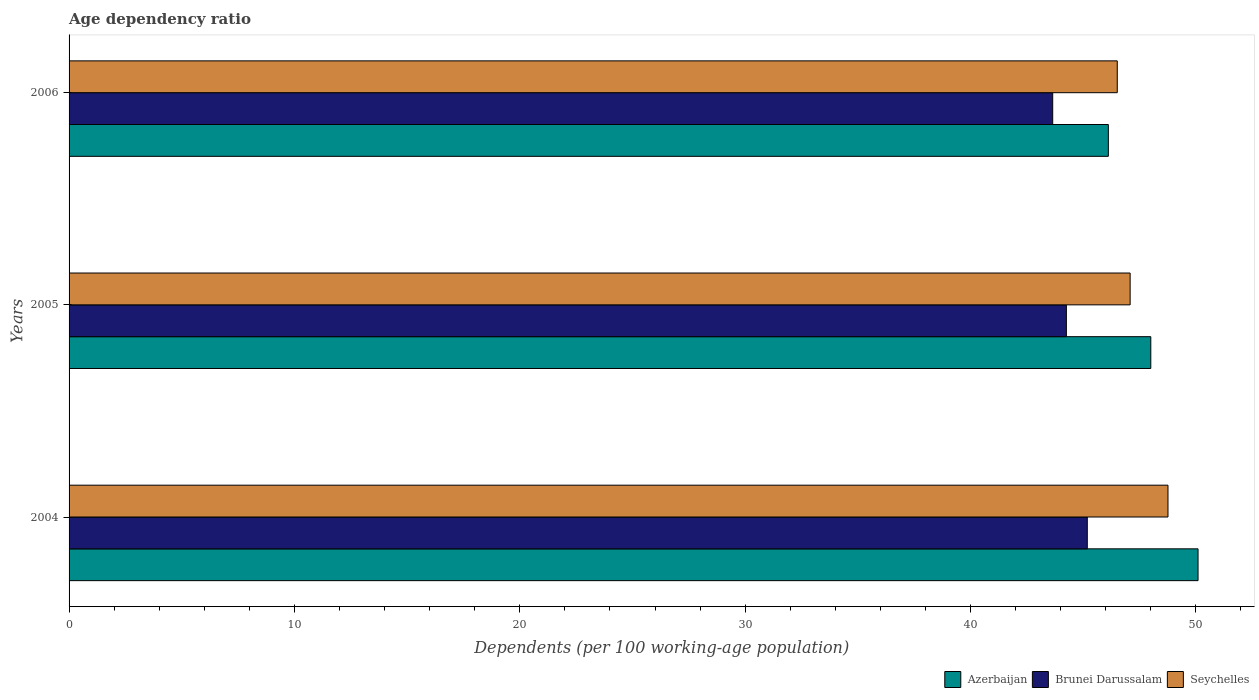How many groups of bars are there?
Provide a short and direct response. 3. Are the number of bars per tick equal to the number of legend labels?
Provide a short and direct response. Yes. How many bars are there on the 2nd tick from the top?
Your answer should be compact. 3. How many bars are there on the 2nd tick from the bottom?
Make the answer very short. 3. What is the label of the 2nd group of bars from the top?
Provide a succinct answer. 2005. In how many cases, is the number of bars for a given year not equal to the number of legend labels?
Your response must be concise. 0. What is the age dependency ratio in in Brunei Darussalam in 2006?
Your answer should be compact. 43.65. Across all years, what is the maximum age dependency ratio in in Brunei Darussalam?
Your answer should be very brief. 45.18. Across all years, what is the minimum age dependency ratio in in Brunei Darussalam?
Your response must be concise. 43.65. What is the total age dependency ratio in in Seychelles in the graph?
Your answer should be compact. 142.35. What is the difference between the age dependency ratio in in Azerbaijan in 2005 and that in 2006?
Your response must be concise. 1.88. What is the difference between the age dependency ratio in in Brunei Darussalam in 2004 and the age dependency ratio in in Azerbaijan in 2006?
Provide a succinct answer. -0.93. What is the average age dependency ratio in in Azerbaijan per year?
Make the answer very short. 48.07. In the year 2005, what is the difference between the age dependency ratio in in Azerbaijan and age dependency ratio in in Seychelles?
Ensure brevity in your answer.  0.92. What is the ratio of the age dependency ratio in in Brunei Darussalam in 2005 to that in 2006?
Provide a short and direct response. 1.01. Is the difference between the age dependency ratio in in Azerbaijan in 2004 and 2006 greater than the difference between the age dependency ratio in in Seychelles in 2004 and 2006?
Your answer should be very brief. Yes. What is the difference between the highest and the second highest age dependency ratio in in Brunei Darussalam?
Keep it short and to the point. 0.93. What is the difference between the highest and the lowest age dependency ratio in in Brunei Darussalam?
Give a very brief answer. 1.53. Is the sum of the age dependency ratio in in Seychelles in 2005 and 2006 greater than the maximum age dependency ratio in in Azerbaijan across all years?
Offer a terse response. Yes. What does the 2nd bar from the top in 2006 represents?
Provide a short and direct response. Brunei Darussalam. What does the 2nd bar from the bottom in 2006 represents?
Keep it short and to the point. Brunei Darussalam. Is it the case that in every year, the sum of the age dependency ratio in in Brunei Darussalam and age dependency ratio in in Azerbaijan is greater than the age dependency ratio in in Seychelles?
Your response must be concise. Yes. How many bars are there?
Your answer should be compact. 9. Are all the bars in the graph horizontal?
Keep it short and to the point. Yes. How many years are there in the graph?
Your answer should be very brief. 3. Does the graph contain any zero values?
Provide a short and direct response. No. Does the graph contain grids?
Give a very brief answer. No. What is the title of the graph?
Your answer should be compact. Age dependency ratio. Does "Czech Republic" appear as one of the legend labels in the graph?
Keep it short and to the point. No. What is the label or title of the X-axis?
Your answer should be very brief. Dependents (per 100 working-age population). What is the Dependents (per 100 working-age population) of Azerbaijan in 2004?
Offer a very short reply. 50.1. What is the Dependents (per 100 working-age population) in Brunei Darussalam in 2004?
Your response must be concise. 45.18. What is the Dependents (per 100 working-age population) of Seychelles in 2004?
Offer a very short reply. 48.76. What is the Dependents (per 100 working-age population) of Azerbaijan in 2005?
Ensure brevity in your answer.  48. What is the Dependents (per 100 working-age population) of Brunei Darussalam in 2005?
Your response must be concise. 44.25. What is the Dependents (per 100 working-age population) of Seychelles in 2005?
Offer a very short reply. 47.08. What is the Dependents (per 100 working-age population) in Azerbaijan in 2006?
Provide a succinct answer. 46.12. What is the Dependents (per 100 working-age population) in Brunei Darussalam in 2006?
Give a very brief answer. 43.65. What is the Dependents (per 100 working-age population) in Seychelles in 2006?
Your answer should be very brief. 46.51. Across all years, what is the maximum Dependents (per 100 working-age population) of Azerbaijan?
Your response must be concise. 50.1. Across all years, what is the maximum Dependents (per 100 working-age population) in Brunei Darussalam?
Offer a very short reply. 45.18. Across all years, what is the maximum Dependents (per 100 working-age population) of Seychelles?
Your response must be concise. 48.76. Across all years, what is the minimum Dependents (per 100 working-age population) of Azerbaijan?
Offer a very short reply. 46.12. Across all years, what is the minimum Dependents (per 100 working-age population) of Brunei Darussalam?
Your response must be concise. 43.65. Across all years, what is the minimum Dependents (per 100 working-age population) of Seychelles?
Keep it short and to the point. 46.51. What is the total Dependents (per 100 working-age population) in Azerbaijan in the graph?
Make the answer very short. 144.21. What is the total Dependents (per 100 working-age population) in Brunei Darussalam in the graph?
Keep it short and to the point. 133.08. What is the total Dependents (per 100 working-age population) in Seychelles in the graph?
Your answer should be compact. 142.35. What is the difference between the Dependents (per 100 working-age population) of Azerbaijan in 2004 and that in 2005?
Offer a very short reply. 2.1. What is the difference between the Dependents (per 100 working-age population) in Brunei Darussalam in 2004 and that in 2005?
Your answer should be compact. 0.93. What is the difference between the Dependents (per 100 working-age population) of Seychelles in 2004 and that in 2005?
Provide a succinct answer. 1.68. What is the difference between the Dependents (per 100 working-age population) of Azerbaijan in 2004 and that in 2006?
Offer a very short reply. 3.98. What is the difference between the Dependents (per 100 working-age population) of Brunei Darussalam in 2004 and that in 2006?
Provide a short and direct response. 1.53. What is the difference between the Dependents (per 100 working-age population) in Seychelles in 2004 and that in 2006?
Give a very brief answer. 2.25. What is the difference between the Dependents (per 100 working-age population) in Azerbaijan in 2005 and that in 2006?
Offer a terse response. 1.88. What is the difference between the Dependents (per 100 working-age population) of Brunei Darussalam in 2005 and that in 2006?
Ensure brevity in your answer.  0.61. What is the difference between the Dependents (per 100 working-age population) in Seychelles in 2005 and that in 2006?
Ensure brevity in your answer.  0.57. What is the difference between the Dependents (per 100 working-age population) of Azerbaijan in 2004 and the Dependents (per 100 working-age population) of Brunei Darussalam in 2005?
Keep it short and to the point. 5.84. What is the difference between the Dependents (per 100 working-age population) of Azerbaijan in 2004 and the Dependents (per 100 working-age population) of Seychelles in 2005?
Make the answer very short. 3.01. What is the difference between the Dependents (per 100 working-age population) of Brunei Darussalam in 2004 and the Dependents (per 100 working-age population) of Seychelles in 2005?
Your answer should be compact. -1.9. What is the difference between the Dependents (per 100 working-age population) of Azerbaijan in 2004 and the Dependents (per 100 working-age population) of Brunei Darussalam in 2006?
Offer a terse response. 6.45. What is the difference between the Dependents (per 100 working-age population) of Azerbaijan in 2004 and the Dependents (per 100 working-age population) of Seychelles in 2006?
Your answer should be very brief. 3.58. What is the difference between the Dependents (per 100 working-age population) in Brunei Darussalam in 2004 and the Dependents (per 100 working-age population) in Seychelles in 2006?
Keep it short and to the point. -1.33. What is the difference between the Dependents (per 100 working-age population) in Azerbaijan in 2005 and the Dependents (per 100 working-age population) in Brunei Darussalam in 2006?
Your answer should be very brief. 4.35. What is the difference between the Dependents (per 100 working-age population) in Azerbaijan in 2005 and the Dependents (per 100 working-age population) in Seychelles in 2006?
Ensure brevity in your answer.  1.49. What is the difference between the Dependents (per 100 working-age population) in Brunei Darussalam in 2005 and the Dependents (per 100 working-age population) in Seychelles in 2006?
Your answer should be compact. -2.26. What is the average Dependents (per 100 working-age population) of Azerbaijan per year?
Provide a short and direct response. 48.07. What is the average Dependents (per 100 working-age population) in Brunei Darussalam per year?
Provide a short and direct response. 44.36. What is the average Dependents (per 100 working-age population) of Seychelles per year?
Provide a short and direct response. 47.45. In the year 2004, what is the difference between the Dependents (per 100 working-age population) in Azerbaijan and Dependents (per 100 working-age population) in Brunei Darussalam?
Your answer should be compact. 4.91. In the year 2004, what is the difference between the Dependents (per 100 working-age population) in Azerbaijan and Dependents (per 100 working-age population) in Seychelles?
Your answer should be very brief. 1.33. In the year 2004, what is the difference between the Dependents (per 100 working-age population) in Brunei Darussalam and Dependents (per 100 working-age population) in Seychelles?
Your answer should be compact. -3.58. In the year 2005, what is the difference between the Dependents (per 100 working-age population) of Azerbaijan and Dependents (per 100 working-age population) of Brunei Darussalam?
Keep it short and to the point. 3.75. In the year 2005, what is the difference between the Dependents (per 100 working-age population) in Brunei Darussalam and Dependents (per 100 working-age population) in Seychelles?
Provide a short and direct response. -2.83. In the year 2006, what is the difference between the Dependents (per 100 working-age population) in Azerbaijan and Dependents (per 100 working-age population) in Brunei Darussalam?
Provide a succinct answer. 2.47. In the year 2006, what is the difference between the Dependents (per 100 working-age population) in Azerbaijan and Dependents (per 100 working-age population) in Seychelles?
Your response must be concise. -0.4. In the year 2006, what is the difference between the Dependents (per 100 working-age population) in Brunei Darussalam and Dependents (per 100 working-age population) in Seychelles?
Offer a very short reply. -2.86. What is the ratio of the Dependents (per 100 working-age population) of Azerbaijan in 2004 to that in 2005?
Give a very brief answer. 1.04. What is the ratio of the Dependents (per 100 working-age population) in Brunei Darussalam in 2004 to that in 2005?
Provide a short and direct response. 1.02. What is the ratio of the Dependents (per 100 working-age population) in Seychelles in 2004 to that in 2005?
Provide a short and direct response. 1.04. What is the ratio of the Dependents (per 100 working-age population) in Azerbaijan in 2004 to that in 2006?
Offer a terse response. 1.09. What is the ratio of the Dependents (per 100 working-age population) of Brunei Darussalam in 2004 to that in 2006?
Give a very brief answer. 1.04. What is the ratio of the Dependents (per 100 working-age population) in Seychelles in 2004 to that in 2006?
Your answer should be very brief. 1.05. What is the ratio of the Dependents (per 100 working-age population) in Azerbaijan in 2005 to that in 2006?
Offer a terse response. 1.04. What is the ratio of the Dependents (per 100 working-age population) in Brunei Darussalam in 2005 to that in 2006?
Provide a short and direct response. 1.01. What is the ratio of the Dependents (per 100 working-age population) of Seychelles in 2005 to that in 2006?
Provide a short and direct response. 1.01. What is the difference between the highest and the second highest Dependents (per 100 working-age population) of Azerbaijan?
Your answer should be compact. 2.1. What is the difference between the highest and the second highest Dependents (per 100 working-age population) of Brunei Darussalam?
Offer a terse response. 0.93. What is the difference between the highest and the second highest Dependents (per 100 working-age population) of Seychelles?
Ensure brevity in your answer.  1.68. What is the difference between the highest and the lowest Dependents (per 100 working-age population) of Azerbaijan?
Keep it short and to the point. 3.98. What is the difference between the highest and the lowest Dependents (per 100 working-age population) of Brunei Darussalam?
Your response must be concise. 1.53. What is the difference between the highest and the lowest Dependents (per 100 working-age population) of Seychelles?
Offer a terse response. 2.25. 